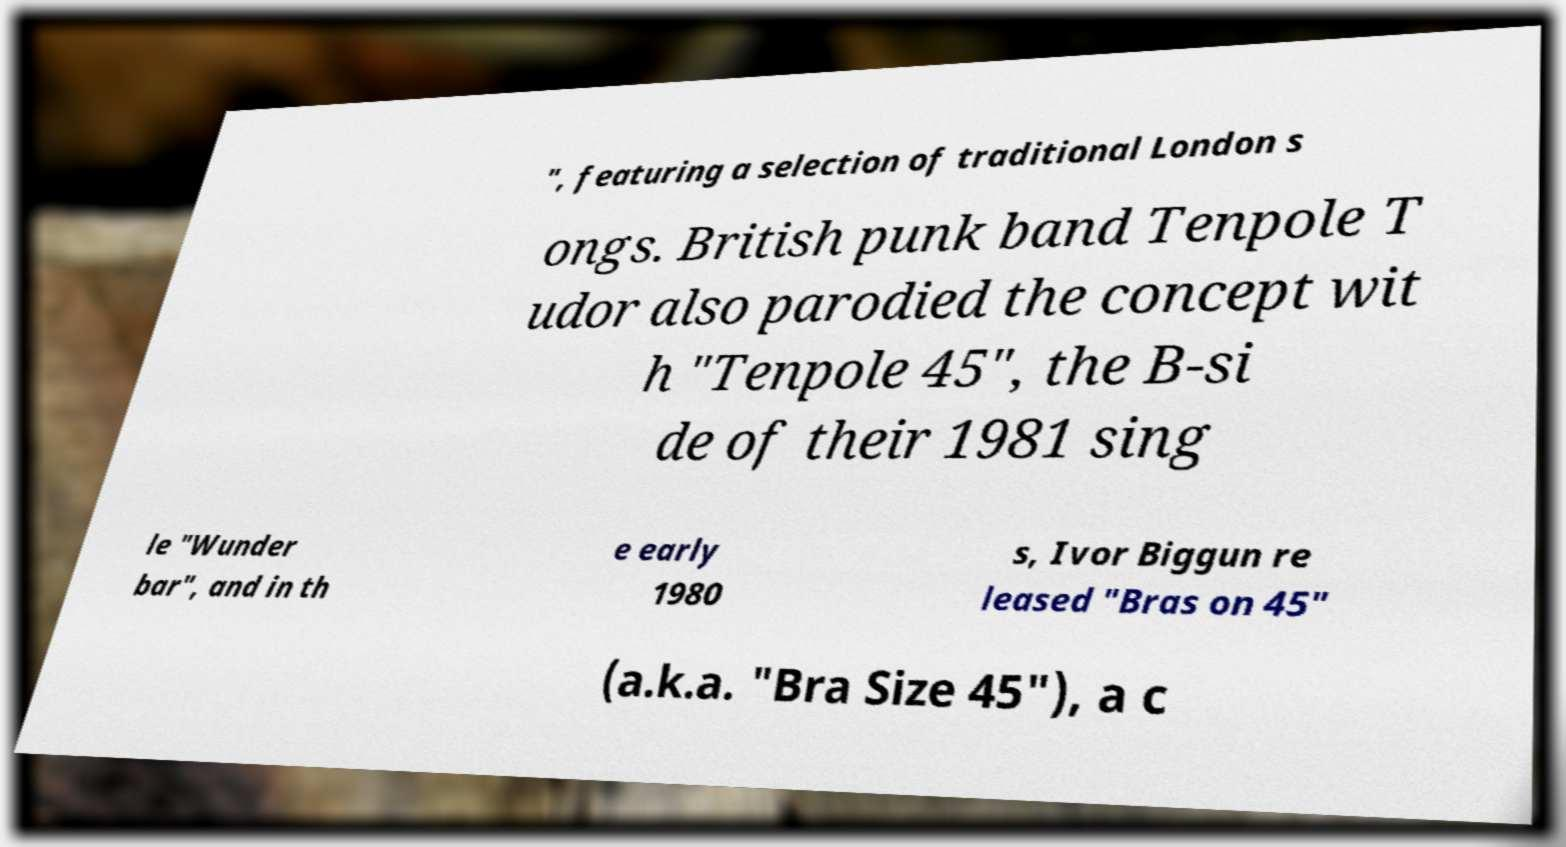Can you read and provide the text displayed in the image?This photo seems to have some interesting text. Can you extract and type it out for me? ", featuring a selection of traditional London s ongs. British punk band Tenpole T udor also parodied the concept wit h "Tenpole 45", the B-si de of their 1981 sing le "Wunder bar", and in th e early 1980 s, Ivor Biggun re leased "Bras on 45" (a.k.a. "Bra Size 45"), a c 